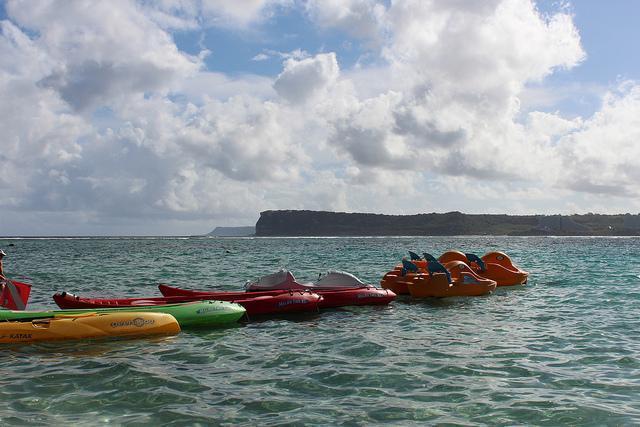What is one of the biggest risks in this environment?
Answer the question by selecting the correct answer among the 4 following choices.
Options: Drowning, assault, dog assault, asphyxiation. Drowning. 